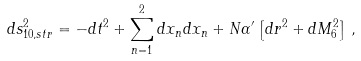<formula> <loc_0><loc_0><loc_500><loc_500>d s ^ { 2 } _ { 1 0 , s t r } = - d t ^ { 2 } + \sum _ { n = 1 } ^ { 2 } d x _ { n } d x _ { n } + N \alpha ^ { \prime } \left [ d r ^ { 2 } + d M ^ { 2 } _ { 6 } \right ] \, ,</formula> 